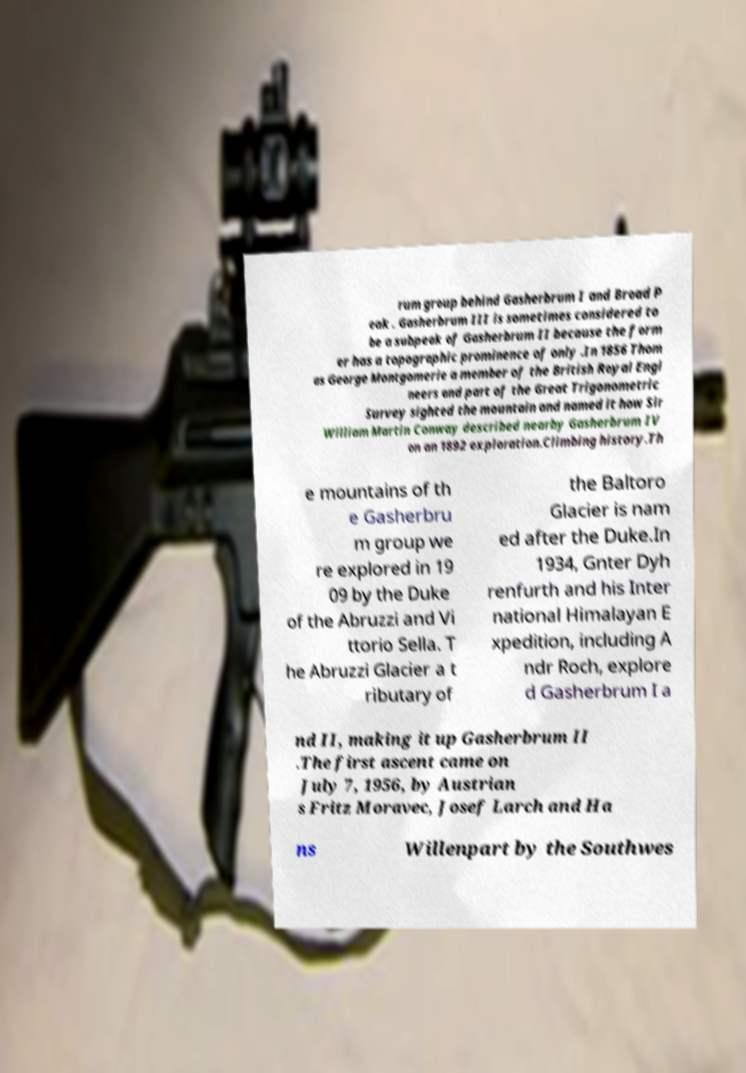Please read and relay the text visible in this image. What does it say? rum group behind Gasherbrum I and Broad P eak . Gasherbrum III is sometimes considered to be a subpeak of Gasherbrum II because the form er has a topographic prominence of only .In 1856 Thom as George Montgomerie a member of the British Royal Engi neers and part of the Great Trigonometric Survey sighted the mountain and named it how Sir William Martin Conway described nearby Gasherbrum IV on an 1892 exploration.Climbing history.Th e mountains of th e Gasherbru m group we re explored in 19 09 by the Duke of the Abruzzi and Vi ttorio Sella. T he Abruzzi Glacier a t ributary of the Baltoro Glacier is nam ed after the Duke.In 1934, Gnter Dyh renfurth and his Inter national Himalayan E xpedition, including A ndr Roch, explore d Gasherbrum I a nd II, making it up Gasherbrum II .The first ascent came on July 7, 1956, by Austrian s Fritz Moravec, Josef Larch and Ha ns Willenpart by the Southwes 